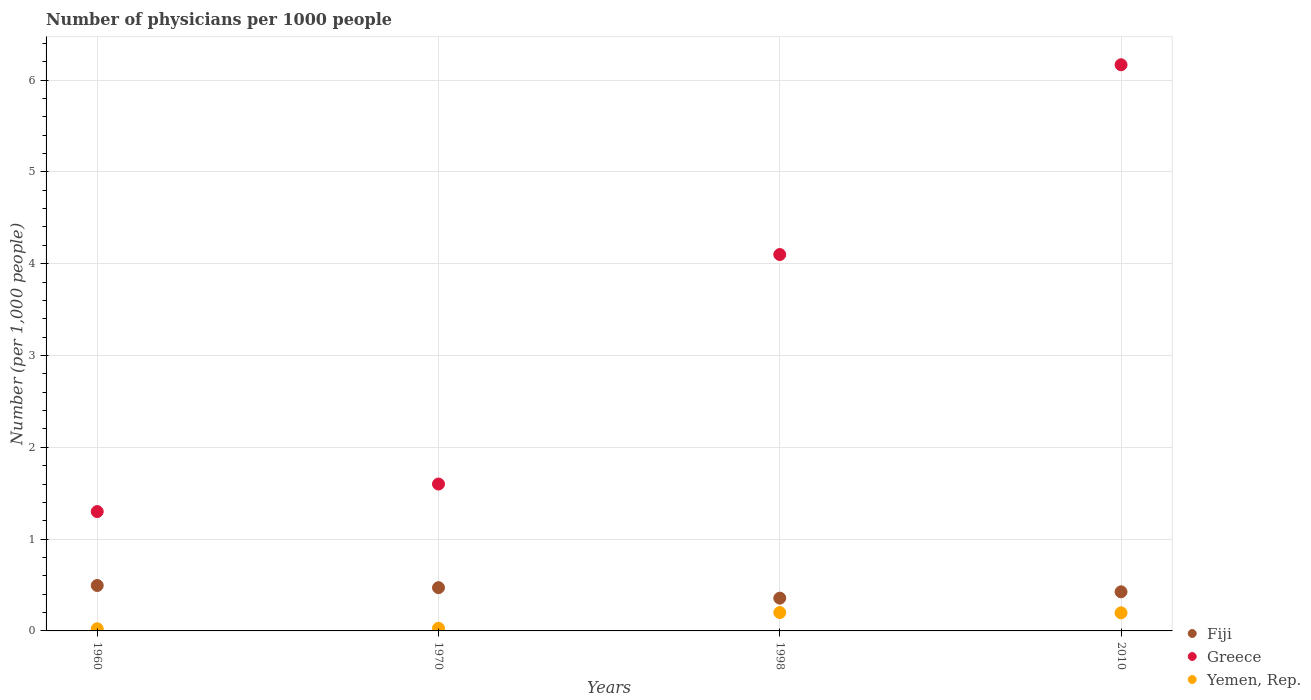Across all years, what is the maximum number of physicians in Fiji?
Your answer should be compact. 0.49. In which year was the number of physicians in Greece minimum?
Make the answer very short. 1960. What is the total number of physicians in Yemen, Rep. in the graph?
Ensure brevity in your answer.  0.45. What is the difference between the number of physicians in Fiji in 1960 and that in 2010?
Provide a short and direct response. 0.07. What is the difference between the number of physicians in Yemen, Rep. in 1998 and the number of physicians in Fiji in 1960?
Provide a short and direct response. -0.29. What is the average number of physicians in Fiji per year?
Your answer should be very brief. 0.44. In the year 2010, what is the difference between the number of physicians in Fiji and number of physicians in Yemen, Rep.?
Provide a succinct answer. 0.23. In how many years, is the number of physicians in Fiji greater than 1?
Your answer should be very brief. 0. What is the ratio of the number of physicians in Yemen, Rep. in 1960 to that in 1998?
Offer a terse response. 0.12. Is the number of physicians in Yemen, Rep. in 1998 less than that in 2010?
Provide a short and direct response. No. What is the difference between the highest and the second highest number of physicians in Greece?
Provide a succinct answer. 2.07. What is the difference between the highest and the lowest number of physicians in Greece?
Your response must be concise. 4.87. Is the number of physicians in Fiji strictly greater than the number of physicians in Yemen, Rep. over the years?
Your response must be concise. Yes. How many dotlines are there?
Provide a short and direct response. 3. How many years are there in the graph?
Keep it short and to the point. 4. What is the difference between two consecutive major ticks on the Y-axis?
Offer a very short reply. 1. Does the graph contain any zero values?
Make the answer very short. No. How many legend labels are there?
Your answer should be compact. 3. What is the title of the graph?
Your answer should be compact. Number of physicians per 1000 people. What is the label or title of the X-axis?
Ensure brevity in your answer.  Years. What is the label or title of the Y-axis?
Your answer should be very brief. Number (per 1,0 people). What is the Number (per 1,000 people) in Fiji in 1960?
Keep it short and to the point. 0.49. What is the Number (per 1,000 people) in Yemen, Rep. in 1960?
Provide a short and direct response. 0.02. What is the Number (per 1,000 people) in Fiji in 1970?
Your answer should be very brief. 0.47. What is the Number (per 1,000 people) of Yemen, Rep. in 1970?
Ensure brevity in your answer.  0.03. What is the Number (per 1,000 people) of Fiji in 1998?
Give a very brief answer. 0.36. What is the Number (per 1,000 people) of Fiji in 2010?
Keep it short and to the point. 0.43. What is the Number (per 1,000 people) in Greece in 2010?
Provide a succinct answer. 6.17. What is the Number (per 1,000 people) in Yemen, Rep. in 2010?
Provide a succinct answer. 0.2. Across all years, what is the maximum Number (per 1,000 people) of Fiji?
Offer a very short reply. 0.49. Across all years, what is the maximum Number (per 1,000 people) in Greece?
Give a very brief answer. 6.17. Across all years, what is the maximum Number (per 1,000 people) in Yemen, Rep.?
Provide a succinct answer. 0.2. Across all years, what is the minimum Number (per 1,000 people) of Fiji?
Make the answer very short. 0.36. Across all years, what is the minimum Number (per 1,000 people) of Greece?
Offer a very short reply. 1.3. Across all years, what is the minimum Number (per 1,000 people) of Yemen, Rep.?
Your answer should be very brief. 0.02. What is the total Number (per 1,000 people) in Fiji in the graph?
Offer a very short reply. 1.75. What is the total Number (per 1,000 people) of Greece in the graph?
Keep it short and to the point. 13.17. What is the total Number (per 1,000 people) in Yemen, Rep. in the graph?
Make the answer very short. 0.45. What is the difference between the Number (per 1,000 people) of Fiji in 1960 and that in 1970?
Offer a terse response. 0.02. What is the difference between the Number (per 1,000 people) in Yemen, Rep. in 1960 and that in 1970?
Your response must be concise. -0.01. What is the difference between the Number (per 1,000 people) of Fiji in 1960 and that in 1998?
Keep it short and to the point. 0.14. What is the difference between the Number (per 1,000 people) of Yemen, Rep. in 1960 and that in 1998?
Provide a succinct answer. -0.18. What is the difference between the Number (per 1,000 people) in Fiji in 1960 and that in 2010?
Provide a succinct answer. 0.07. What is the difference between the Number (per 1,000 people) of Greece in 1960 and that in 2010?
Your answer should be very brief. -4.87. What is the difference between the Number (per 1,000 people) of Yemen, Rep. in 1960 and that in 2010?
Your answer should be compact. -0.17. What is the difference between the Number (per 1,000 people) in Fiji in 1970 and that in 1998?
Provide a short and direct response. 0.11. What is the difference between the Number (per 1,000 people) in Yemen, Rep. in 1970 and that in 1998?
Make the answer very short. -0.17. What is the difference between the Number (per 1,000 people) of Fiji in 1970 and that in 2010?
Provide a short and direct response. 0.05. What is the difference between the Number (per 1,000 people) of Greece in 1970 and that in 2010?
Keep it short and to the point. -4.57. What is the difference between the Number (per 1,000 people) in Yemen, Rep. in 1970 and that in 2010?
Your answer should be very brief. -0.17. What is the difference between the Number (per 1,000 people) of Fiji in 1998 and that in 2010?
Your response must be concise. -0.07. What is the difference between the Number (per 1,000 people) of Greece in 1998 and that in 2010?
Offer a very short reply. -2.07. What is the difference between the Number (per 1,000 people) in Yemen, Rep. in 1998 and that in 2010?
Your response must be concise. 0. What is the difference between the Number (per 1,000 people) of Fiji in 1960 and the Number (per 1,000 people) of Greece in 1970?
Provide a short and direct response. -1.11. What is the difference between the Number (per 1,000 people) in Fiji in 1960 and the Number (per 1,000 people) in Yemen, Rep. in 1970?
Your answer should be compact. 0.47. What is the difference between the Number (per 1,000 people) in Greece in 1960 and the Number (per 1,000 people) in Yemen, Rep. in 1970?
Your answer should be compact. 1.27. What is the difference between the Number (per 1,000 people) in Fiji in 1960 and the Number (per 1,000 people) in Greece in 1998?
Offer a very short reply. -3.61. What is the difference between the Number (per 1,000 people) in Fiji in 1960 and the Number (per 1,000 people) in Yemen, Rep. in 1998?
Offer a terse response. 0.29. What is the difference between the Number (per 1,000 people) of Fiji in 1960 and the Number (per 1,000 people) of Greece in 2010?
Offer a very short reply. -5.67. What is the difference between the Number (per 1,000 people) in Fiji in 1960 and the Number (per 1,000 people) in Yemen, Rep. in 2010?
Provide a short and direct response. 0.3. What is the difference between the Number (per 1,000 people) of Greece in 1960 and the Number (per 1,000 people) of Yemen, Rep. in 2010?
Make the answer very short. 1.1. What is the difference between the Number (per 1,000 people) in Fiji in 1970 and the Number (per 1,000 people) in Greece in 1998?
Give a very brief answer. -3.63. What is the difference between the Number (per 1,000 people) in Fiji in 1970 and the Number (per 1,000 people) in Yemen, Rep. in 1998?
Offer a terse response. 0.27. What is the difference between the Number (per 1,000 people) of Fiji in 1970 and the Number (per 1,000 people) of Greece in 2010?
Your answer should be very brief. -5.7. What is the difference between the Number (per 1,000 people) of Fiji in 1970 and the Number (per 1,000 people) of Yemen, Rep. in 2010?
Offer a very short reply. 0.27. What is the difference between the Number (per 1,000 people) of Greece in 1970 and the Number (per 1,000 people) of Yemen, Rep. in 2010?
Your answer should be compact. 1.4. What is the difference between the Number (per 1,000 people) in Fiji in 1998 and the Number (per 1,000 people) in Greece in 2010?
Keep it short and to the point. -5.81. What is the difference between the Number (per 1,000 people) of Fiji in 1998 and the Number (per 1,000 people) of Yemen, Rep. in 2010?
Keep it short and to the point. 0.16. What is the difference between the Number (per 1,000 people) in Greece in 1998 and the Number (per 1,000 people) in Yemen, Rep. in 2010?
Your answer should be very brief. 3.9. What is the average Number (per 1,000 people) in Fiji per year?
Your answer should be very brief. 0.44. What is the average Number (per 1,000 people) of Greece per year?
Your response must be concise. 3.29. What is the average Number (per 1,000 people) in Yemen, Rep. per year?
Keep it short and to the point. 0.11. In the year 1960, what is the difference between the Number (per 1,000 people) in Fiji and Number (per 1,000 people) in Greece?
Give a very brief answer. -0.81. In the year 1960, what is the difference between the Number (per 1,000 people) of Fiji and Number (per 1,000 people) of Yemen, Rep.?
Ensure brevity in your answer.  0.47. In the year 1960, what is the difference between the Number (per 1,000 people) of Greece and Number (per 1,000 people) of Yemen, Rep.?
Keep it short and to the point. 1.28. In the year 1970, what is the difference between the Number (per 1,000 people) of Fiji and Number (per 1,000 people) of Greece?
Your response must be concise. -1.13. In the year 1970, what is the difference between the Number (per 1,000 people) in Fiji and Number (per 1,000 people) in Yemen, Rep.?
Your answer should be compact. 0.44. In the year 1970, what is the difference between the Number (per 1,000 people) in Greece and Number (per 1,000 people) in Yemen, Rep.?
Offer a terse response. 1.57. In the year 1998, what is the difference between the Number (per 1,000 people) of Fiji and Number (per 1,000 people) of Greece?
Your answer should be compact. -3.74. In the year 1998, what is the difference between the Number (per 1,000 people) of Fiji and Number (per 1,000 people) of Yemen, Rep.?
Offer a terse response. 0.16. In the year 2010, what is the difference between the Number (per 1,000 people) of Fiji and Number (per 1,000 people) of Greece?
Your answer should be very brief. -5.74. In the year 2010, what is the difference between the Number (per 1,000 people) in Fiji and Number (per 1,000 people) in Yemen, Rep.?
Provide a succinct answer. 0.23. In the year 2010, what is the difference between the Number (per 1,000 people) in Greece and Number (per 1,000 people) in Yemen, Rep.?
Offer a very short reply. 5.97. What is the ratio of the Number (per 1,000 people) in Fiji in 1960 to that in 1970?
Your response must be concise. 1.05. What is the ratio of the Number (per 1,000 people) of Greece in 1960 to that in 1970?
Provide a succinct answer. 0.81. What is the ratio of the Number (per 1,000 people) of Yemen, Rep. in 1960 to that in 1970?
Your response must be concise. 0.82. What is the ratio of the Number (per 1,000 people) in Fiji in 1960 to that in 1998?
Your answer should be very brief. 1.39. What is the ratio of the Number (per 1,000 people) in Greece in 1960 to that in 1998?
Ensure brevity in your answer.  0.32. What is the ratio of the Number (per 1,000 people) in Yemen, Rep. in 1960 to that in 1998?
Provide a short and direct response. 0.12. What is the ratio of the Number (per 1,000 people) of Fiji in 1960 to that in 2010?
Provide a short and direct response. 1.16. What is the ratio of the Number (per 1,000 people) of Greece in 1960 to that in 2010?
Ensure brevity in your answer.  0.21. What is the ratio of the Number (per 1,000 people) in Yemen, Rep. in 1960 to that in 2010?
Provide a succinct answer. 0.12. What is the ratio of the Number (per 1,000 people) of Fiji in 1970 to that in 1998?
Your answer should be compact. 1.32. What is the ratio of the Number (per 1,000 people) in Greece in 1970 to that in 1998?
Your response must be concise. 0.39. What is the ratio of the Number (per 1,000 people) of Yemen, Rep. in 1970 to that in 1998?
Offer a very short reply. 0.14. What is the ratio of the Number (per 1,000 people) of Fiji in 1970 to that in 2010?
Give a very brief answer. 1.11. What is the ratio of the Number (per 1,000 people) of Greece in 1970 to that in 2010?
Make the answer very short. 0.26. What is the ratio of the Number (per 1,000 people) of Yemen, Rep. in 1970 to that in 2010?
Your answer should be compact. 0.15. What is the ratio of the Number (per 1,000 people) of Fiji in 1998 to that in 2010?
Your response must be concise. 0.84. What is the ratio of the Number (per 1,000 people) in Greece in 1998 to that in 2010?
Provide a succinct answer. 0.66. What is the ratio of the Number (per 1,000 people) in Yemen, Rep. in 1998 to that in 2010?
Keep it short and to the point. 1.02. What is the difference between the highest and the second highest Number (per 1,000 people) of Fiji?
Your response must be concise. 0.02. What is the difference between the highest and the second highest Number (per 1,000 people) of Greece?
Your answer should be very brief. 2.07. What is the difference between the highest and the second highest Number (per 1,000 people) of Yemen, Rep.?
Keep it short and to the point. 0. What is the difference between the highest and the lowest Number (per 1,000 people) of Fiji?
Provide a short and direct response. 0.14. What is the difference between the highest and the lowest Number (per 1,000 people) in Greece?
Your answer should be compact. 4.87. What is the difference between the highest and the lowest Number (per 1,000 people) of Yemen, Rep.?
Ensure brevity in your answer.  0.18. 